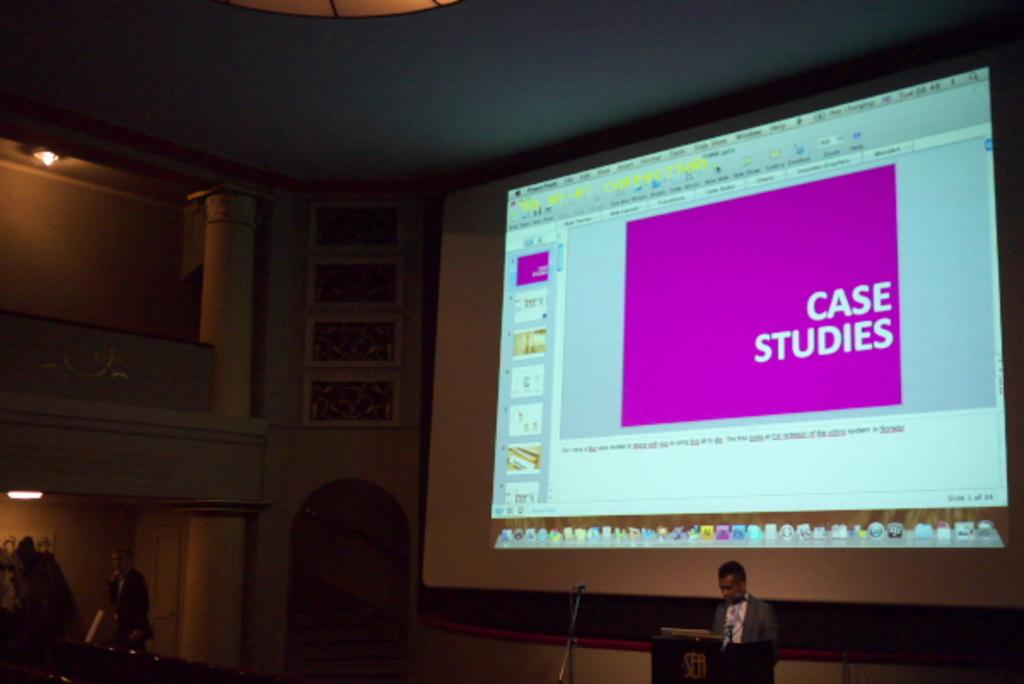<image>
Give a short and clear explanation of the subsequent image. A speaker on stage using a powerpoint on screen to cover Case Stories. 